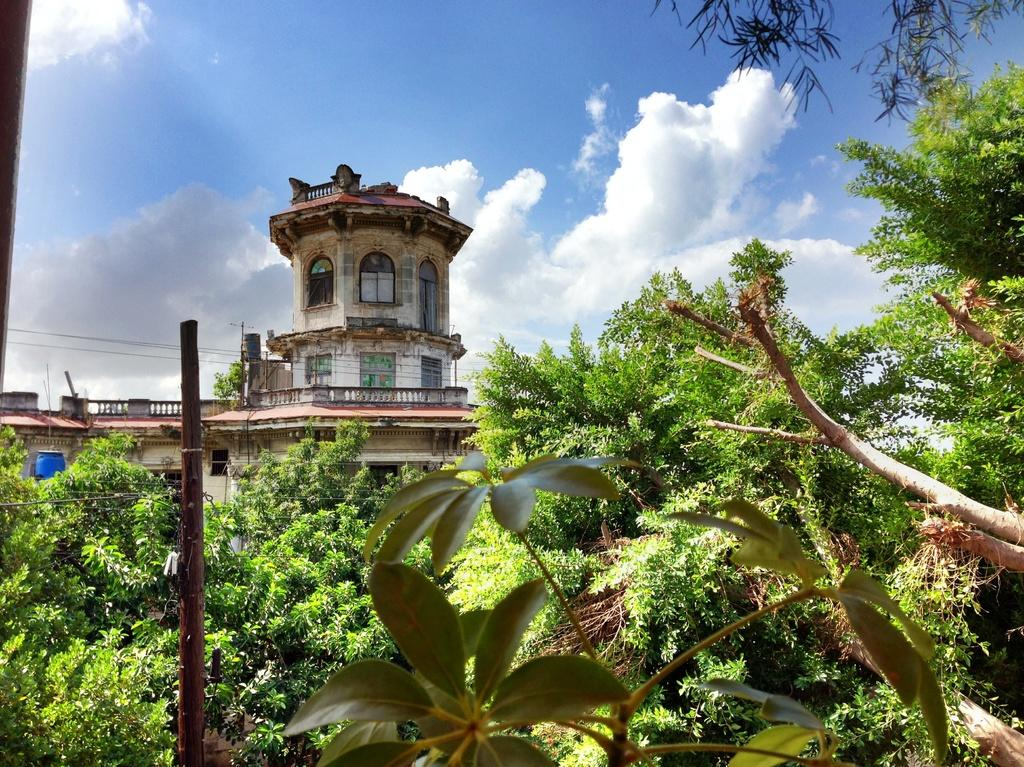What type of living organisms can be seen in the image? Plants and trees are visible in the image. What is the tall, vertical object in the image? There is a pole in the image. What can be seen in the background of the image? Trees, a building, clouds, and the sky are visible in the background of the image. Who is the owner of the lamp in the image? There is no lamp present in the image. What type of muscle can be seen in the image? There are no muscles visible in the image; it features plants, trees, a pole, and background elements. 